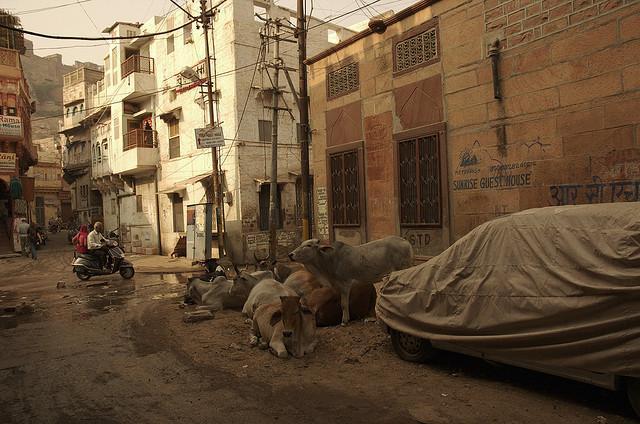How many cows are in the photo?
Give a very brief answer. 2. How many surfboards are there?
Give a very brief answer. 0. 